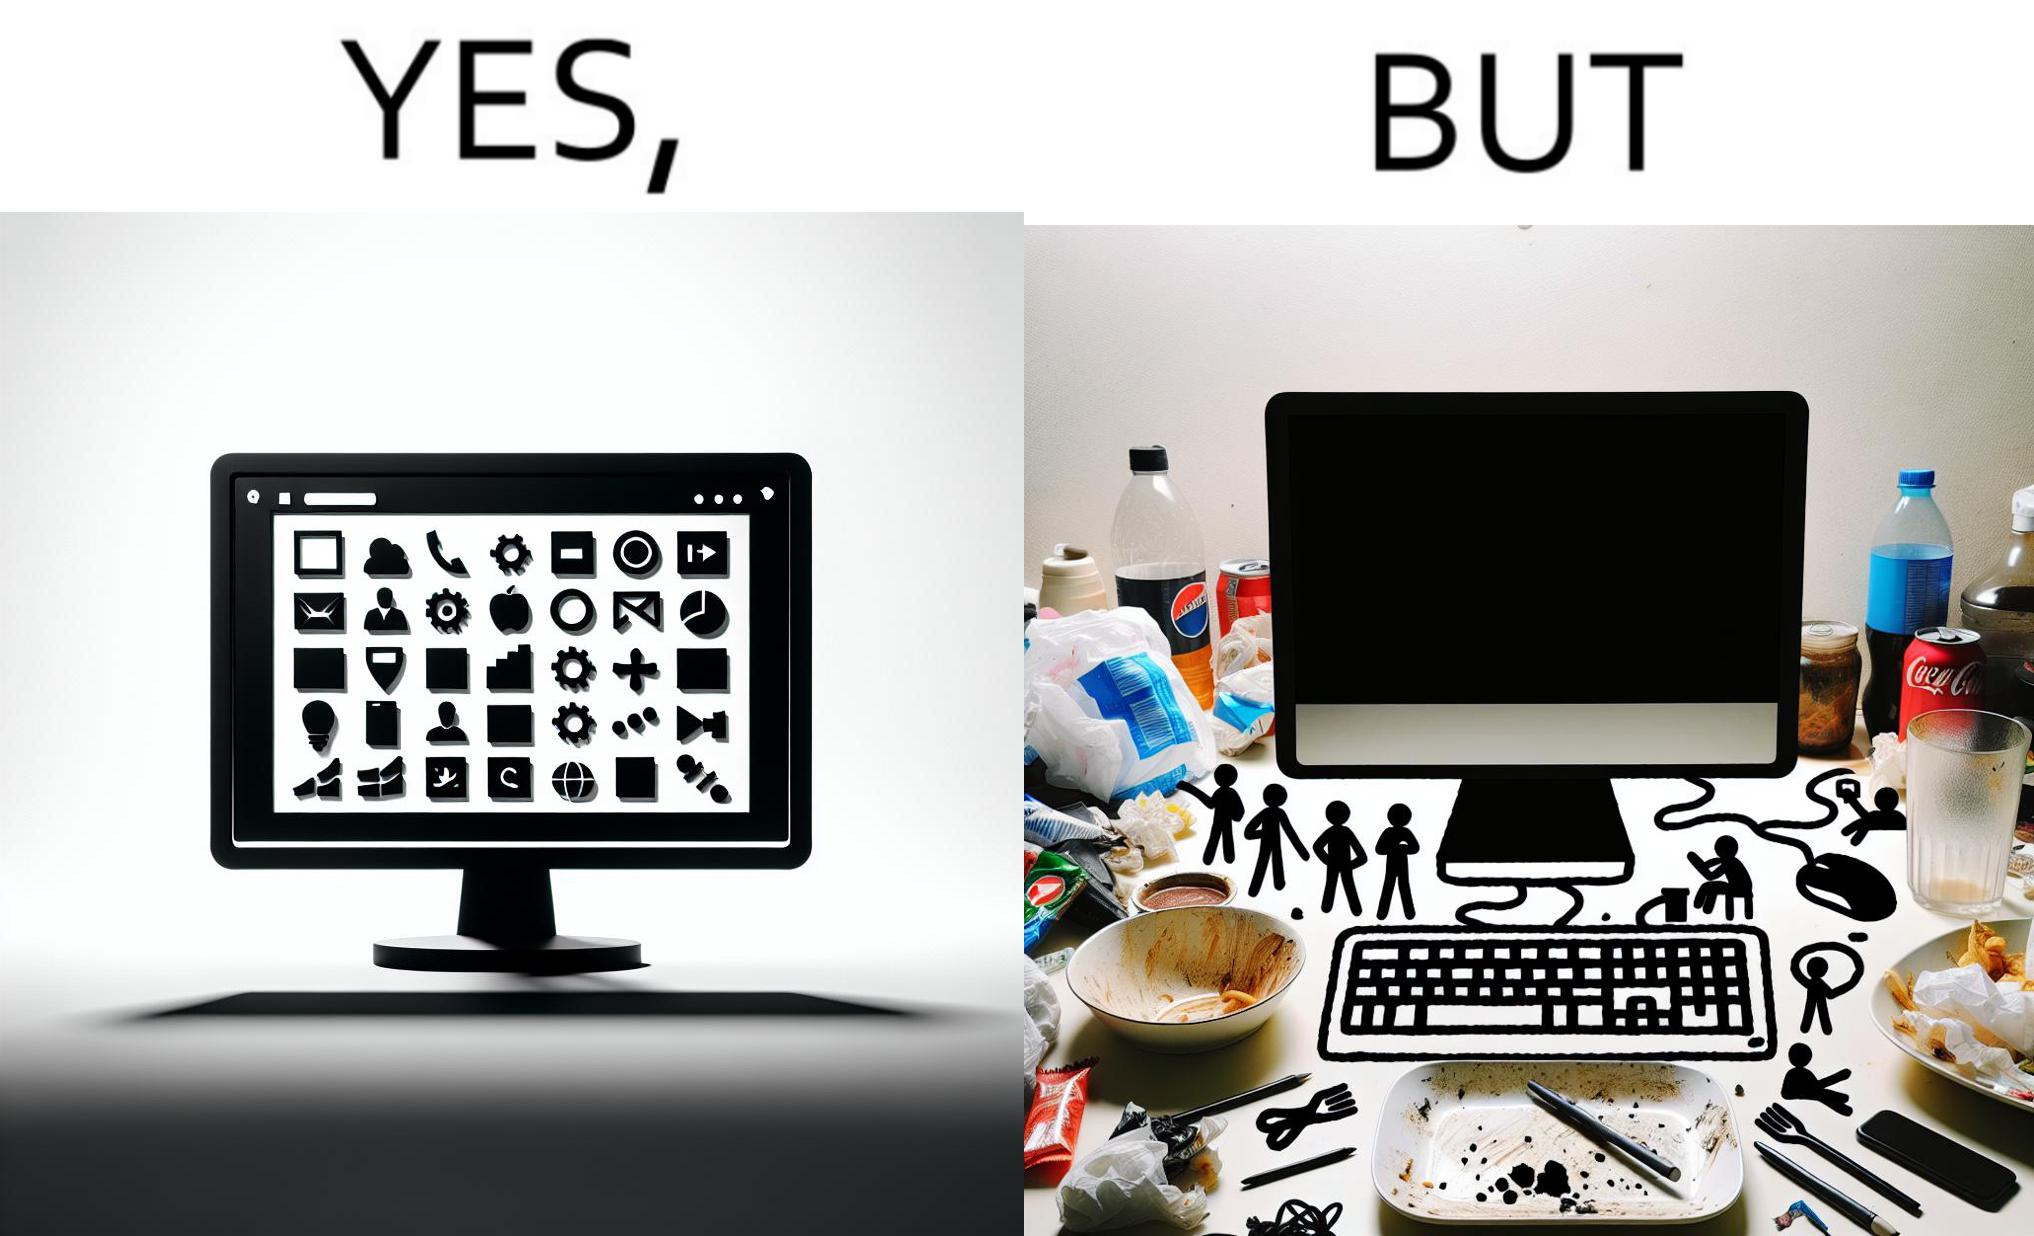Explain the humor or irony in this image. The image is ironical, as the folder icons on the desktop screen are very neatly arranged, while the person using the computer has littered the table with used food packets, dirty plates, and wrappers. 